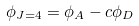<formula> <loc_0><loc_0><loc_500><loc_500>\phi _ { J = 4 } = \phi _ { A } - c \phi _ { D }</formula> 